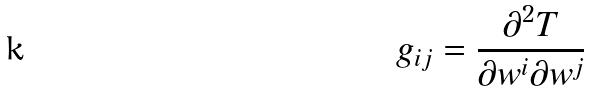Convert formula to latex. <formula><loc_0><loc_0><loc_500><loc_500>g _ { i j } = \frac { \partial ^ { 2 } T } { \partial w ^ { i } \partial w ^ { j } }</formula> 